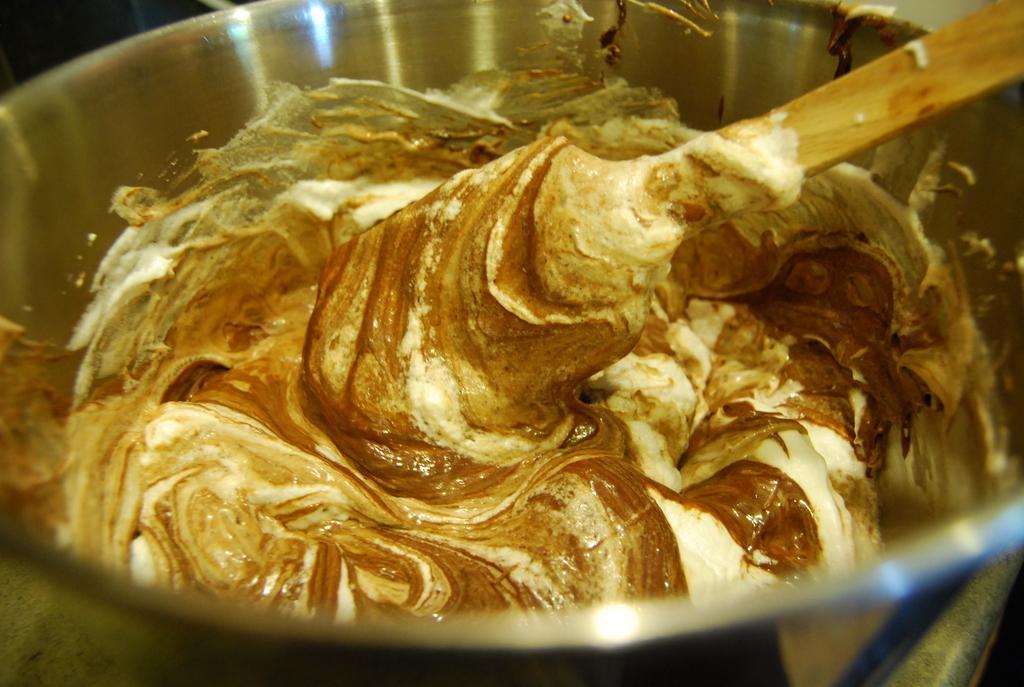Please provide a concise description of this image. In this image we can see a bowl containing butter and there is a ladle. 